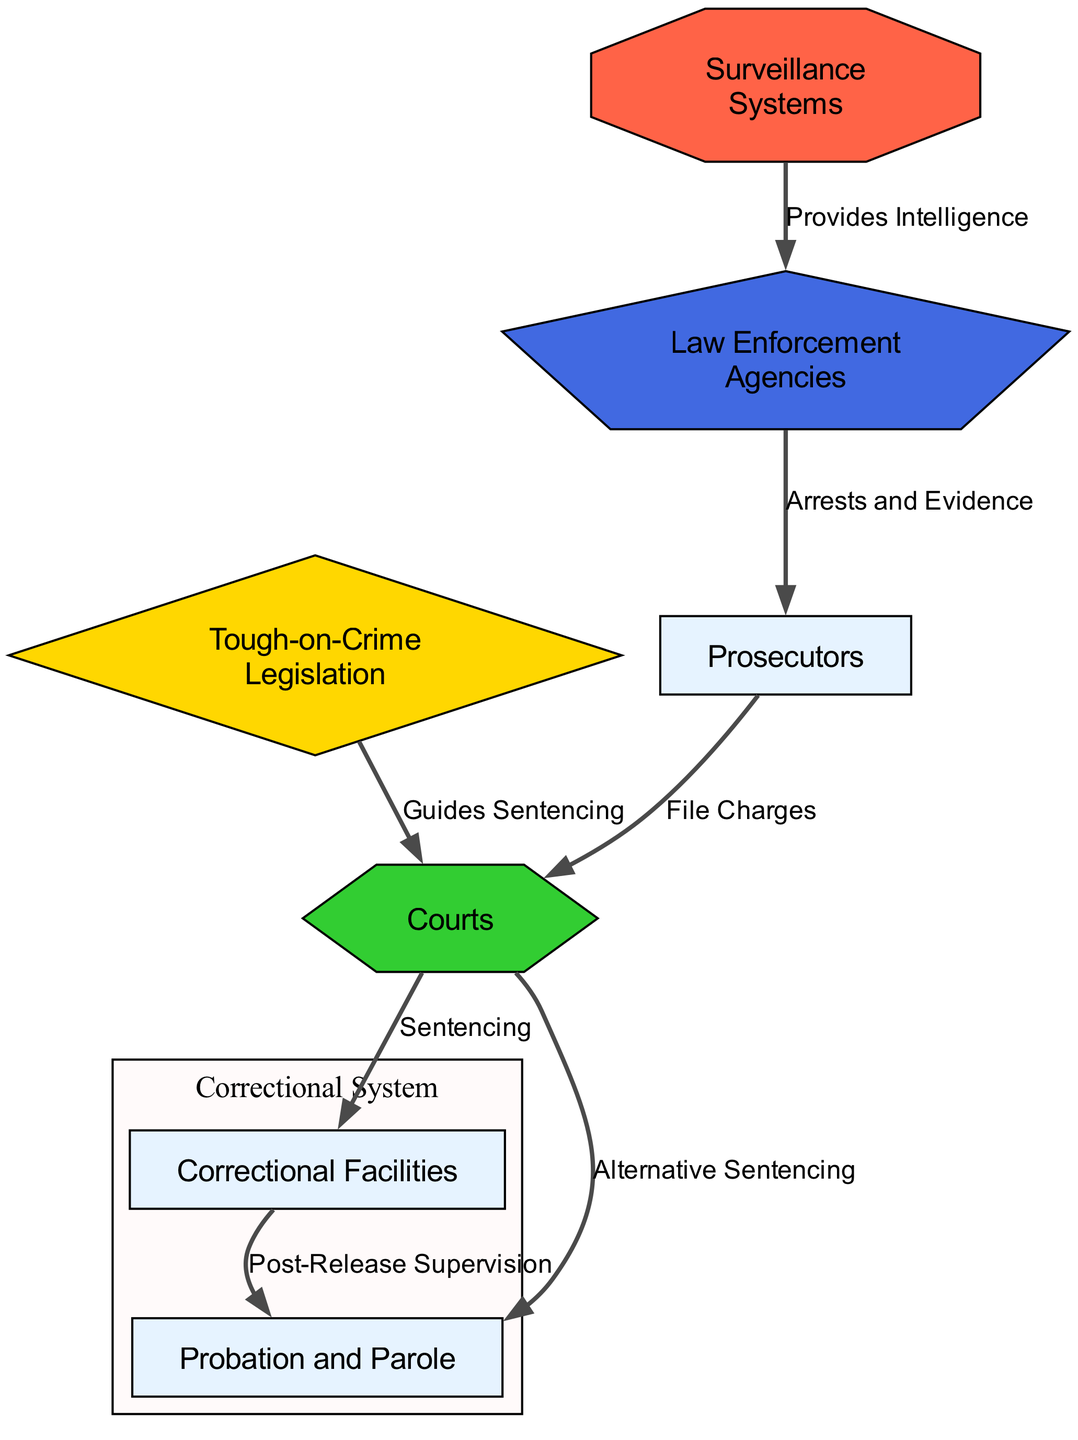What are the primary components of the criminal justice system depicted in the diagram? The diagram shows six primary components: Law Enforcement Agencies, Courts, Prosecutors, Correctional Facilities, Probation and Parole, and Tough-on-Crime Legislation.
Answer: Law Enforcement Agencies, Courts, Prosecutors, Correctional Facilities, Probation and Parole, Tough-on-Crime Legislation How many nodes are present in the diagram? There are six nodes representing various components of the criminal justice system, which are listed in the nodes section of the data.
Answer: 6 What type of edge connects Law Enforcement Agencies to Prosecutors? The edge between Law Enforcement Agencies and Prosecutors is labeled "Arrests and Evidence," indicating the nature of the relationship.
Answer: Arrests and Evidence Which node is connected to Courts through the edge labeled "Guides Sentencing"? The edge labeled "Guides Sentencing" connects Tough-on-Crime Legislation to Courts, indicating that legislation influences court decisions on sentencing.
Answer: Tough-on-Crime Legislation What is the role of Surveillance Systems in relation to Law Enforcement Agencies? Surveillance Systems provide intelligence to Law Enforcement Agencies, as indicated by the directed edge in the diagram.
Answer: Provides Intelligence How does the flow from Courts to Correctional Facilities occur based on the diagram? The flow starts from Courts, which lead to Correctional Facilities through the edge labeled "Sentencing." This indicates that courts issue sentences that result in incarceration in correctional facilities.
Answer: Sentencing What type of node is Tough-on-Crime Legislation and how does it interact with the Courts? Tough-on-Crime Legislation is represented as a diamond-shaped node, which guides sentencing decisions made by the Courts, as shown by the directed edge from legislation to courts.
Answer: Guides Sentencing Describe the relationship between Correctional Facilities and Probation. Correctional Facilities and Probation are connected by the edge labeled "Post-Release Supervision," indicating that probation is involved in supervising individuals after their release from correctional facilities.
Answer: Post-Release Supervision Which node type provides intelligence to Law Enforcement Agencies as indicated in the diagram? The node labeled Surveillance Systems, which is shaped like an octagon, provides intelligence to Law Enforcement Agencies, illustrated by the edge directed towards law enforcement.
Answer: Provides Intelligence 